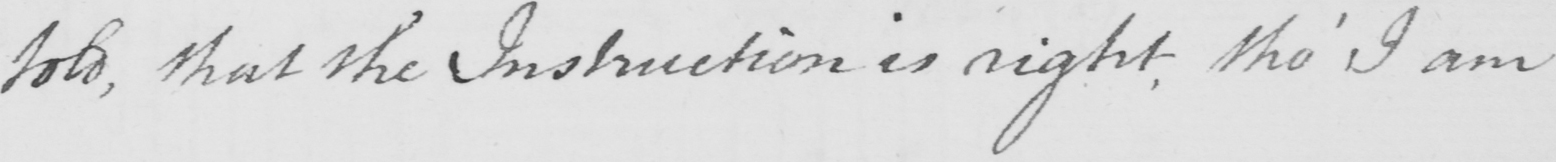What does this handwritten line say? told , that the Instruction is right tho '  I am 